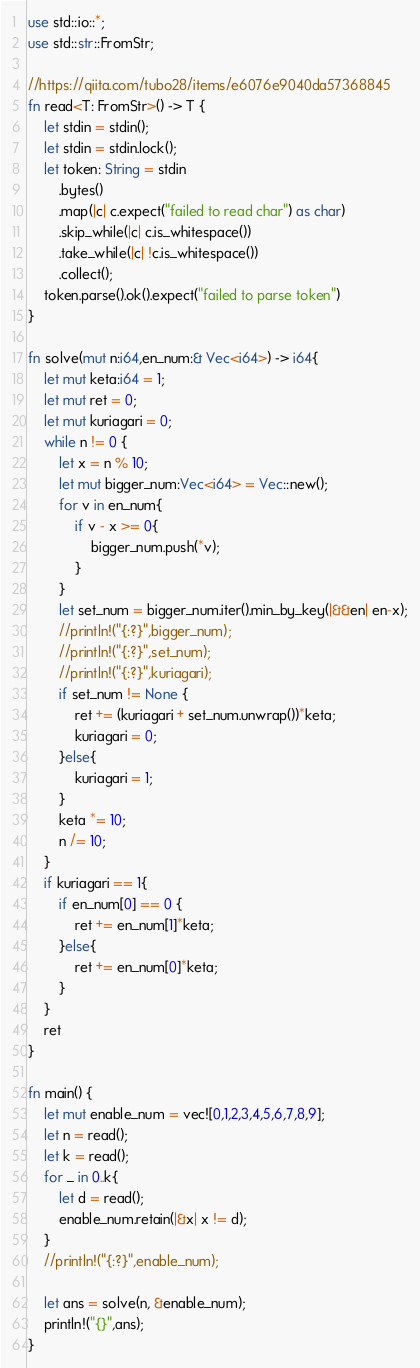Convert code to text. <code><loc_0><loc_0><loc_500><loc_500><_Rust_>use std::io::*;
use std::str::FromStr;

//https://qiita.com/tubo28/items/e6076e9040da57368845
fn read<T: FromStr>() -> T {
    let stdin = stdin();
    let stdin = stdin.lock();
    let token: String = stdin
        .bytes()
        .map(|c| c.expect("failed to read char") as char)
        .skip_while(|c| c.is_whitespace())
        .take_while(|c| !c.is_whitespace())
        .collect();
    token.parse().ok().expect("failed to parse token")
}

fn solve(mut n:i64,en_num:& Vec<i64>) -> i64{
    let mut keta:i64 = 1;
    let mut ret = 0;
    let mut kuriagari = 0;
    while n != 0 {
        let x = n % 10;
        let mut bigger_num:Vec<i64> = Vec::new();
        for v in en_num{
            if v - x >= 0{
                bigger_num.push(*v);
            } 
        }
        let set_num = bigger_num.iter().min_by_key(|&&en| en-x);
        //println!("{:?}",bigger_num);
        //println!("{:?}",set_num);
        //println!("{:?}",kuriagari);
        if set_num != None {
            ret += (kuriagari + set_num.unwrap())*keta;
            kuriagari = 0;
        }else{
            kuriagari = 1;
        }
        keta *= 10;
        n /= 10;
    }
    if kuriagari == 1{
        if en_num[0] == 0 {
            ret += en_num[1]*keta;
        }else{
            ret += en_num[0]*keta;
        }
    }
    ret
}

fn main() {
    let mut enable_num = vec![0,1,2,3,4,5,6,7,8,9];
    let n = read();
    let k = read();
    for _ in 0..k{
        let d = read();
        enable_num.retain(|&x| x != d);
    }
    //println!("{:?}",enable_num);

    let ans = solve(n, &enable_num);
    println!("{}",ans);
}
</code> 